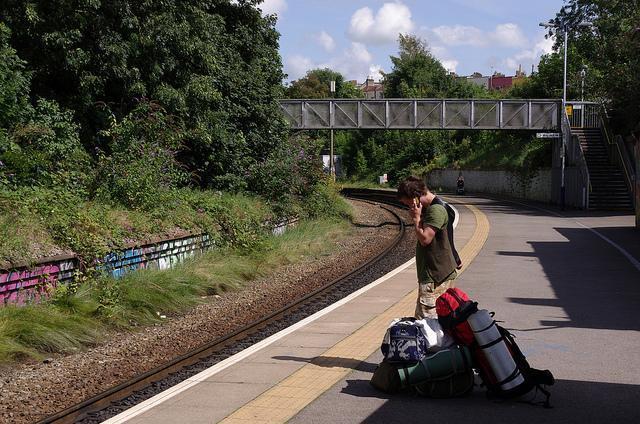If you had to cross to the other side how would you do it?
Select the correct answer and articulate reasoning with the following format: 'Answer: answer
Rationale: rationale.'
Options: Overhead bridge, swing over, cross tracks, take taxi. Answer: overhead bridge.
Rationale: Right in front there is a footbridge. 